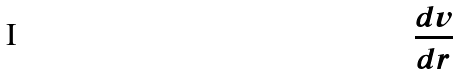<formula> <loc_0><loc_0><loc_500><loc_500>\frac { d v } { d r }</formula> 